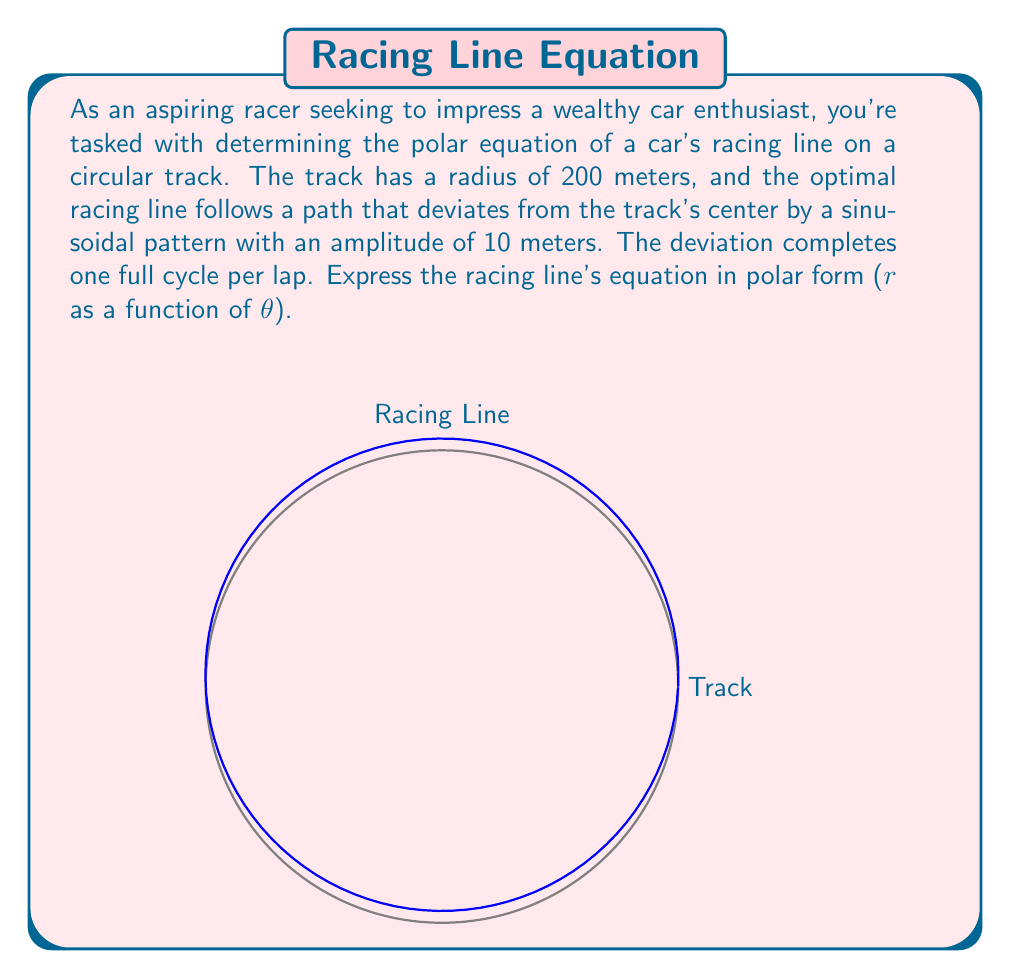Could you help me with this problem? Let's approach this step-by-step:

1) The basic equation of a circle in polar form is $r = R$, where $R$ is the radius. In this case, $R = 200$ meters.

2) The racing line deviates from this circular path by a sinusoidal pattern. This deviation can be represented by $a \sin(\theta)$, where $a$ is the amplitude of the deviation.

3) The amplitude of the deviation is given as 10 meters, so $a = 10$.

4) The deviation completes one full cycle per lap. In polar coordinates, one lap corresponds to $2\pi$ radians. This means our sinusoidal function should have a period of $2\pi$, which it already does in the form $\sin(\theta)$.

5) To get the racing line equation, we add this deviation to the basic circle equation:

   $r = R + a \sin(\theta)$

6) Substituting the values:

   $r = 200 + 10 \sin(\theta)$

This equation represents a circle with a radius that oscillates between 190 and 210 meters as $\theta$ varies from 0 to $2\pi$.
Answer: $r = 200 + 10 \sin(\theta)$ 